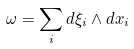Convert formula to latex. <formula><loc_0><loc_0><loc_500><loc_500>\omega = \sum _ { i } d \xi _ { i } \wedge d x _ { i }</formula> 